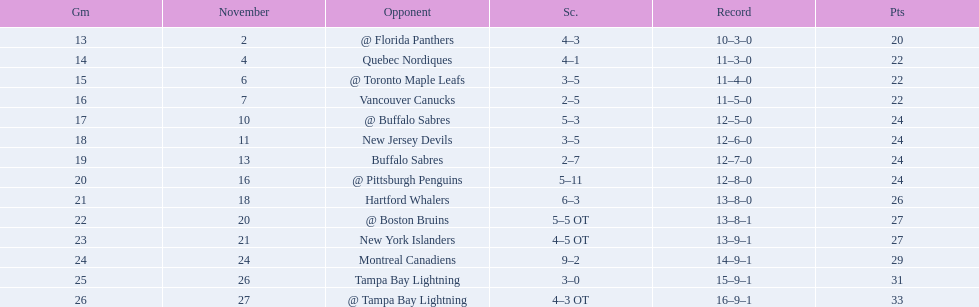What were the scores? @ Florida Panthers, 4–3, Quebec Nordiques, 4–1, @ Toronto Maple Leafs, 3–5, Vancouver Canucks, 2–5, @ Buffalo Sabres, 5–3, New Jersey Devils, 3–5, Buffalo Sabres, 2–7, @ Pittsburgh Penguins, 5–11, Hartford Whalers, 6–3, @ Boston Bruins, 5–5 OT, New York Islanders, 4–5 OT, Montreal Canadiens, 9–2, Tampa Bay Lightning, 3–0, @ Tampa Bay Lightning, 4–3 OT. What score was the closest? New York Islanders, 4–5 OT. What team had that score? New York Islanders. 